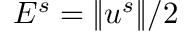Convert formula to latex. <formula><loc_0><loc_0><loc_500><loc_500>E ^ { s } = \| u ^ { s } \| / 2</formula> 